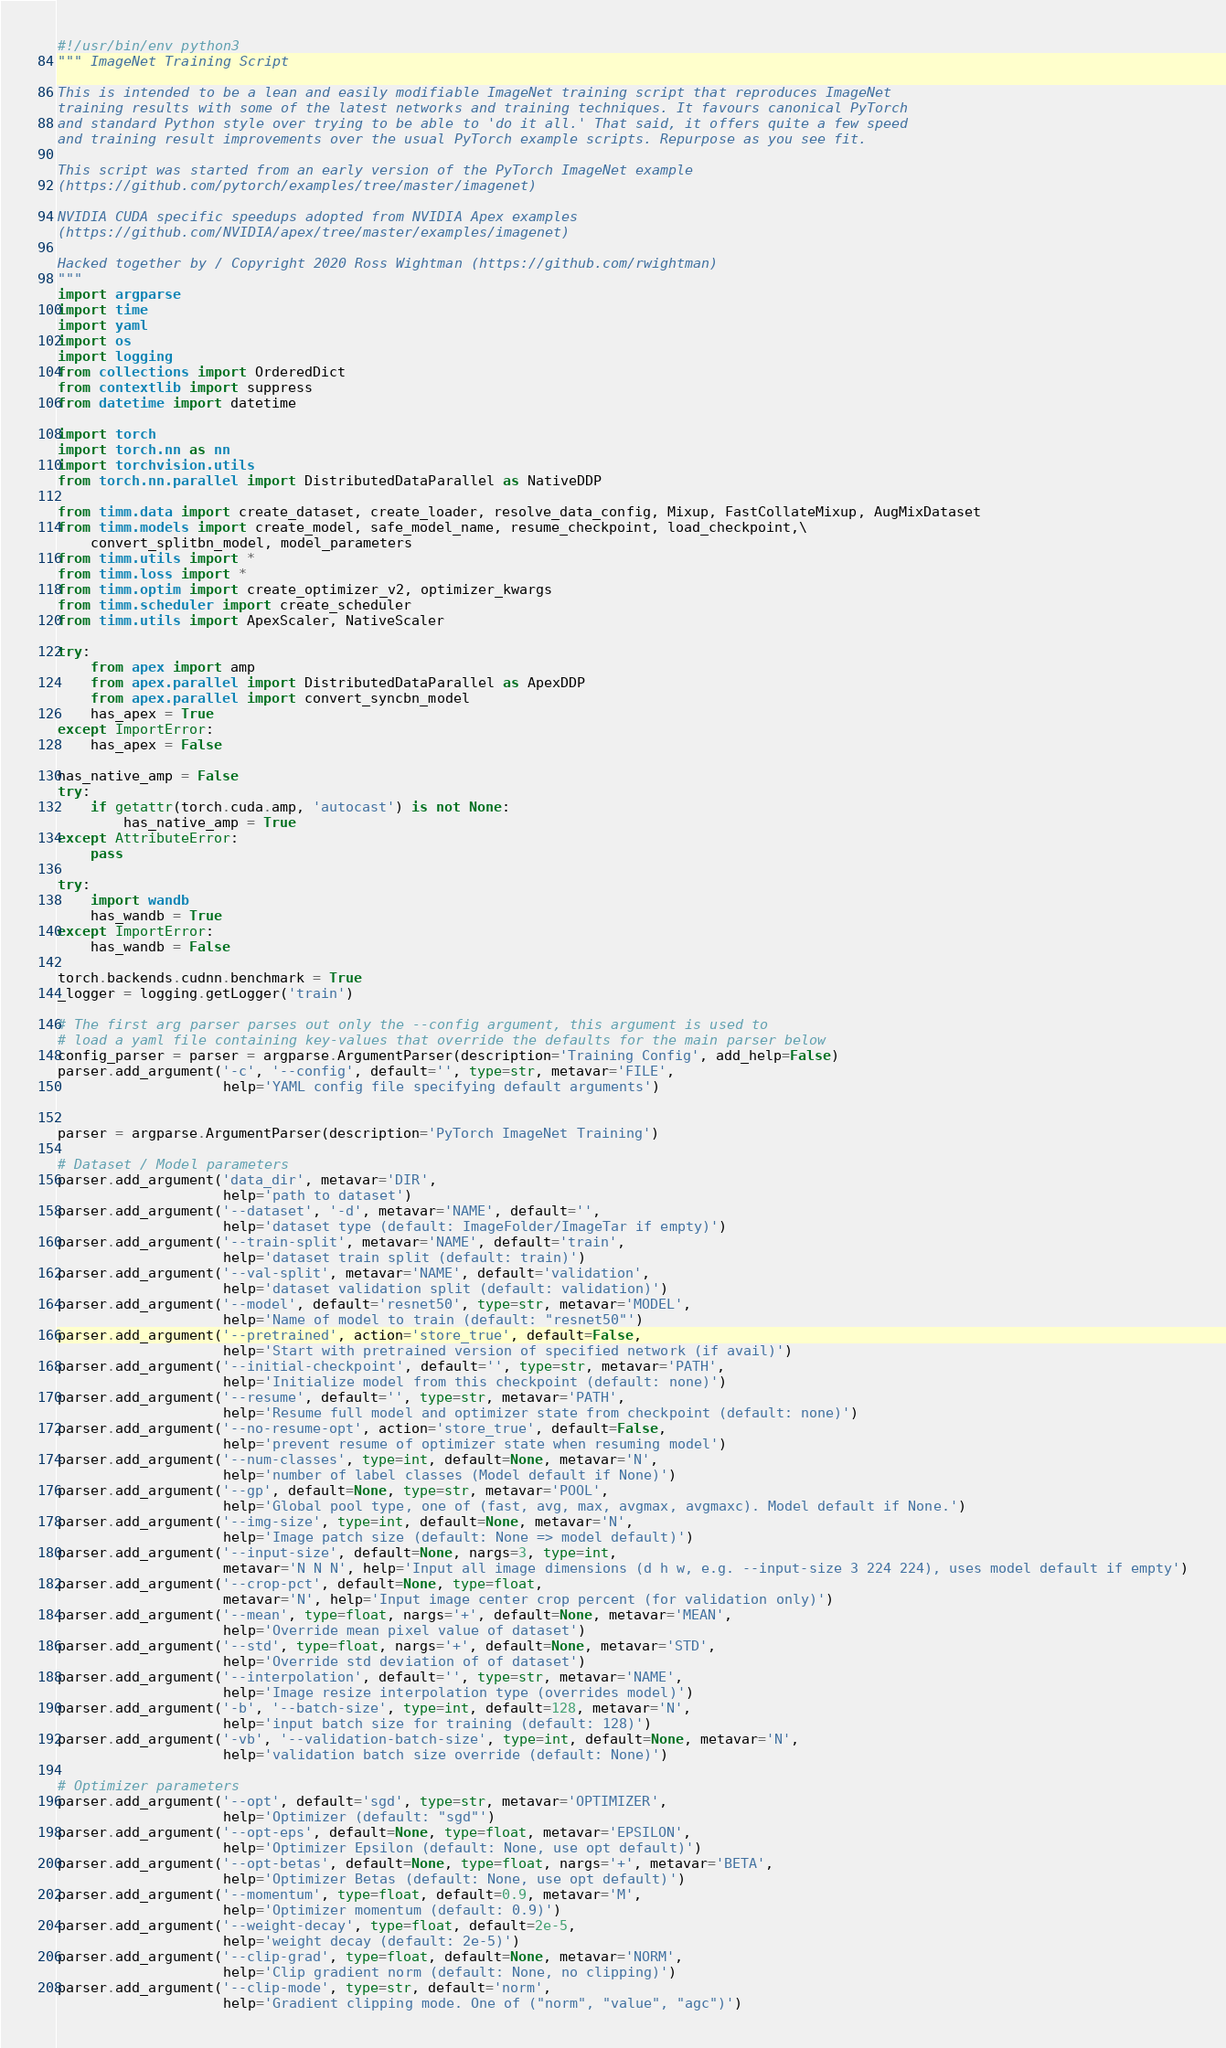<code> <loc_0><loc_0><loc_500><loc_500><_Python_>#!/usr/bin/env python3
""" ImageNet Training Script

This is intended to be a lean and easily modifiable ImageNet training script that reproduces ImageNet
training results with some of the latest networks and training techniques. It favours canonical PyTorch
and standard Python style over trying to be able to 'do it all.' That said, it offers quite a few speed
and training result improvements over the usual PyTorch example scripts. Repurpose as you see fit.

This script was started from an early version of the PyTorch ImageNet example
(https://github.com/pytorch/examples/tree/master/imagenet)

NVIDIA CUDA specific speedups adopted from NVIDIA Apex examples
(https://github.com/NVIDIA/apex/tree/master/examples/imagenet)

Hacked together by / Copyright 2020 Ross Wightman (https://github.com/rwightman)
"""
import argparse
import time
import yaml
import os
import logging
from collections import OrderedDict
from contextlib import suppress
from datetime import datetime

import torch
import torch.nn as nn
import torchvision.utils
from torch.nn.parallel import DistributedDataParallel as NativeDDP

from timm.data import create_dataset, create_loader, resolve_data_config, Mixup, FastCollateMixup, AugMixDataset
from timm.models import create_model, safe_model_name, resume_checkpoint, load_checkpoint,\
    convert_splitbn_model, model_parameters
from timm.utils import *
from timm.loss import *
from timm.optim import create_optimizer_v2, optimizer_kwargs
from timm.scheduler import create_scheduler
from timm.utils import ApexScaler, NativeScaler

try:
    from apex import amp
    from apex.parallel import DistributedDataParallel as ApexDDP
    from apex.parallel import convert_syncbn_model
    has_apex = True
except ImportError:
    has_apex = False

has_native_amp = False
try:
    if getattr(torch.cuda.amp, 'autocast') is not None:
        has_native_amp = True
except AttributeError:
    pass

try:
    import wandb
    has_wandb = True
except ImportError: 
    has_wandb = False

torch.backends.cudnn.benchmark = True
_logger = logging.getLogger('train')

# The first arg parser parses out only the --config argument, this argument is used to
# load a yaml file containing key-values that override the defaults for the main parser below
config_parser = parser = argparse.ArgumentParser(description='Training Config', add_help=False)
parser.add_argument('-c', '--config', default='', type=str, metavar='FILE',
                    help='YAML config file specifying default arguments')


parser = argparse.ArgumentParser(description='PyTorch ImageNet Training')

# Dataset / Model parameters
parser.add_argument('data_dir', metavar='DIR',
                    help='path to dataset')
parser.add_argument('--dataset', '-d', metavar='NAME', default='',
                    help='dataset type (default: ImageFolder/ImageTar if empty)')
parser.add_argument('--train-split', metavar='NAME', default='train',
                    help='dataset train split (default: train)')
parser.add_argument('--val-split', metavar='NAME', default='validation',
                    help='dataset validation split (default: validation)')
parser.add_argument('--model', default='resnet50', type=str, metavar='MODEL',
                    help='Name of model to train (default: "resnet50"')
parser.add_argument('--pretrained', action='store_true', default=False,
                    help='Start with pretrained version of specified network (if avail)')
parser.add_argument('--initial-checkpoint', default='', type=str, metavar='PATH',
                    help='Initialize model from this checkpoint (default: none)')
parser.add_argument('--resume', default='', type=str, metavar='PATH',
                    help='Resume full model and optimizer state from checkpoint (default: none)')
parser.add_argument('--no-resume-opt', action='store_true', default=False,
                    help='prevent resume of optimizer state when resuming model')
parser.add_argument('--num-classes', type=int, default=None, metavar='N',
                    help='number of label classes (Model default if None)')
parser.add_argument('--gp', default=None, type=str, metavar='POOL',
                    help='Global pool type, one of (fast, avg, max, avgmax, avgmaxc). Model default if None.')
parser.add_argument('--img-size', type=int, default=None, metavar='N',
                    help='Image patch size (default: None => model default)')
parser.add_argument('--input-size', default=None, nargs=3, type=int,
                    metavar='N N N', help='Input all image dimensions (d h w, e.g. --input-size 3 224 224), uses model default if empty')
parser.add_argument('--crop-pct', default=None, type=float,
                    metavar='N', help='Input image center crop percent (for validation only)')
parser.add_argument('--mean', type=float, nargs='+', default=None, metavar='MEAN',
                    help='Override mean pixel value of dataset')
parser.add_argument('--std', type=float, nargs='+', default=None, metavar='STD',
                    help='Override std deviation of of dataset')
parser.add_argument('--interpolation', default='', type=str, metavar='NAME',
                    help='Image resize interpolation type (overrides model)')
parser.add_argument('-b', '--batch-size', type=int, default=128, metavar='N',
                    help='input batch size for training (default: 128)')
parser.add_argument('-vb', '--validation-batch-size', type=int, default=None, metavar='N',
                    help='validation batch size override (default: None)')

# Optimizer parameters
parser.add_argument('--opt', default='sgd', type=str, metavar='OPTIMIZER',
                    help='Optimizer (default: "sgd"')
parser.add_argument('--opt-eps', default=None, type=float, metavar='EPSILON',
                    help='Optimizer Epsilon (default: None, use opt default)')
parser.add_argument('--opt-betas', default=None, type=float, nargs='+', metavar='BETA',
                    help='Optimizer Betas (default: None, use opt default)')
parser.add_argument('--momentum', type=float, default=0.9, metavar='M',
                    help='Optimizer momentum (default: 0.9)')
parser.add_argument('--weight-decay', type=float, default=2e-5,
                    help='weight decay (default: 2e-5)')
parser.add_argument('--clip-grad', type=float, default=None, metavar='NORM',
                    help='Clip gradient norm (default: None, no clipping)')
parser.add_argument('--clip-mode', type=str, default='norm',
                    help='Gradient clipping mode. One of ("norm", "value", "agc")')

</code> 